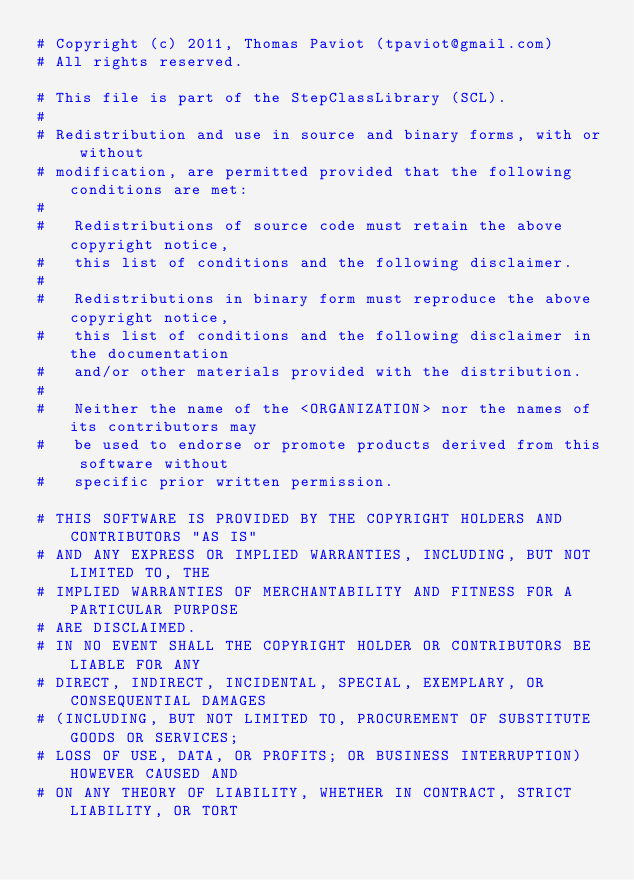Convert code to text. <code><loc_0><loc_0><loc_500><loc_500><_Python_># Copyright (c) 2011, Thomas Paviot (tpaviot@gmail.com)
# All rights reserved.

# This file is part of the StepClassLibrary (SCL).
#
# Redistribution and use in source and binary forms, with or without
# modification, are permitted provided that the following conditions are met:
#
#   Redistributions of source code must retain the above copyright notice,
#   this list of conditions and the following disclaimer.
#
#   Redistributions in binary form must reproduce the above copyright notice,
#   this list of conditions and the following disclaimer in the documentation
#   and/or other materials provided with the distribution.
#
#   Neither the name of the <ORGANIZATION> nor the names of its contributors may
#   be used to endorse or promote products derived from this software without
#   specific prior written permission.

# THIS SOFTWARE IS PROVIDED BY THE COPYRIGHT HOLDERS AND CONTRIBUTORS "AS IS"
# AND ANY EXPRESS OR IMPLIED WARRANTIES, INCLUDING, BUT NOT LIMITED TO, THE
# IMPLIED WARRANTIES OF MERCHANTABILITY AND FITNESS FOR A PARTICULAR PURPOSE
# ARE DISCLAIMED.
# IN NO EVENT SHALL THE COPYRIGHT HOLDER OR CONTRIBUTORS BE LIABLE FOR ANY
# DIRECT, INDIRECT, INCIDENTAL, SPECIAL, EXEMPLARY, OR CONSEQUENTIAL DAMAGES
# (INCLUDING, BUT NOT LIMITED TO, PROCUREMENT OF SUBSTITUTE GOODS OR SERVICES; 
# LOSS OF USE, DATA, OR PROFITS; OR BUSINESS INTERRUPTION) HOWEVER CAUSED AND
# ON ANY THEORY OF LIABILITY, WHETHER IN CONTRACT, STRICT LIABILITY, OR TORT</code> 